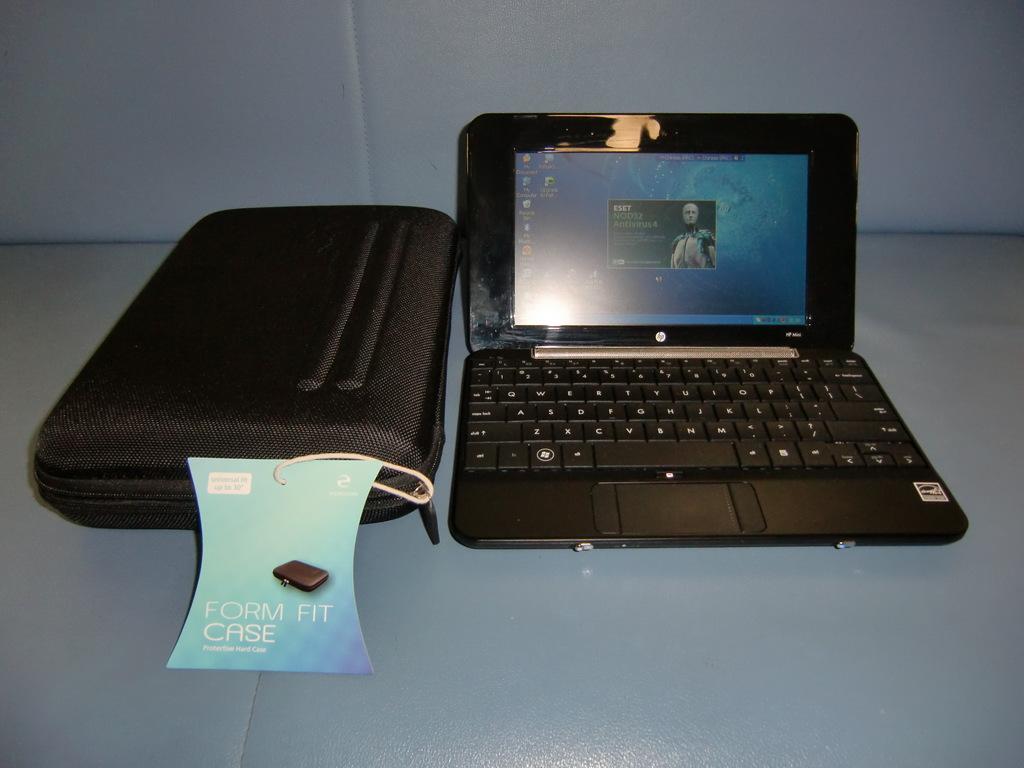What kind of case is shown?
Ensure brevity in your answer.  Form fit case. What word is show in white font on the pop up?
Ensure brevity in your answer.  Eset. 